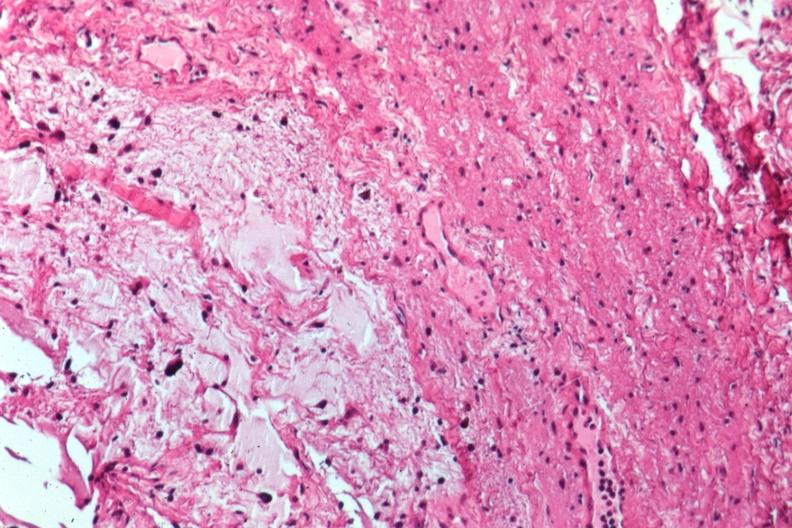does retroperitoneum show glioma?
Answer the question using a single word or phrase. No 